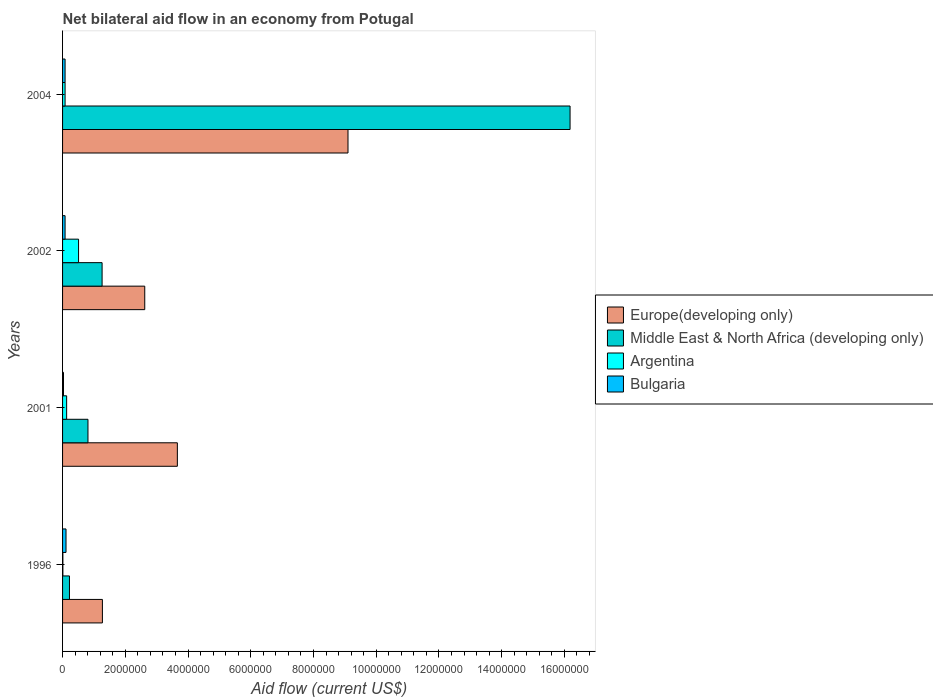How many different coloured bars are there?
Your answer should be very brief. 4. Are the number of bars per tick equal to the number of legend labels?
Offer a very short reply. Yes. Are the number of bars on each tick of the Y-axis equal?
Provide a succinct answer. Yes. What is the net bilateral aid flow in Argentina in 2001?
Provide a short and direct response. 1.30e+05. Across all years, what is the maximum net bilateral aid flow in Middle East & North Africa (developing only)?
Your answer should be very brief. 1.62e+07. In which year was the net bilateral aid flow in Middle East & North Africa (developing only) maximum?
Offer a terse response. 2004. What is the total net bilateral aid flow in Middle East & North Africa (developing only) in the graph?
Your answer should be very brief. 1.85e+07. What is the difference between the net bilateral aid flow in Europe(developing only) in 2001 and that in 2004?
Ensure brevity in your answer.  -5.44e+06. What is the average net bilateral aid flow in Europe(developing only) per year?
Your response must be concise. 4.16e+06. In the year 2004, what is the difference between the net bilateral aid flow in Bulgaria and net bilateral aid flow in Argentina?
Provide a succinct answer. 0. What is the ratio of the net bilateral aid flow in Bulgaria in 2001 to that in 2002?
Your response must be concise. 0.38. Is the net bilateral aid flow in Europe(developing only) in 2002 less than that in 2004?
Give a very brief answer. Yes. What is the difference between the highest and the second highest net bilateral aid flow in Middle East & North Africa (developing only)?
Make the answer very short. 1.49e+07. What is the difference between the highest and the lowest net bilateral aid flow in Bulgaria?
Offer a very short reply. 8.00e+04. Is the sum of the net bilateral aid flow in Argentina in 1996 and 2001 greater than the maximum net bilateral aid flow in Europe(developing only) across all years?
Ensure brevity in your answer.  No. Is it the case that in every year, the sum of the net bilateral aid flow in Middle East & North Africa (developing only) and net bilateral aid flow in Bulgaria is greater than the sum of net bilateral aid flow in Europe(developing only) and net bilateral aid flow in Argentina?
Your answer should be very brief. Yes. What does the 2nd bar from the top in 2002 represents?
Offer a very short reply. Argentina. Is it the case that in every year, the sum of the net bilateral aid flow in Middle East & North Africa (developing only) and net bilateral aid flow in Argentina is greater than the net bilateral aid flow in Europe(developing only)?
Provide a short and direct response. No. How many years are there in the graph?
Give a very brief answer. 4. What is the difference between two consecutive major ticks on the X-axis?
Keep it short and to the point. 2.00e+06. Does the graph contain any zero values?
Offer a very short reply. No. Does the graph contain grids?
Ensure brevity in your answer.  No. Where does the legend appear in the graph?
Offer a terse response. Center right. What is the title of the graph?
Your answer should be compact. Net bilateral aid flow in an economy from Potugal. What is the label or title of the Y-axis?
Ensure brevity in your answer.  Years. What is the Aid flow (current US$) of Europe(developing only) in 1996?
Your answer should be compact. 1.27e+06. What is the Aid flow (current US$) in Argentina in 1996?
Offer a terse response. 10000. What is the Aid flow (current US$) of Europe(developing only) in 2001?
Keep it short and to the point. 3.66e+06. What is the Aid flow (current US$) in Middle East & North Africa (developing only) in 2001?
Give a very brief answer. 8.10e+05. What is the Aid flow (current US$) of Argentina in 2001?
Your response must be concise. 1.30e+05. What is the Aid flow (current US$) in Bulgaria in 2001?
Provide a succinct answer. 3.00e+04. What is the Aid flow (current US$) in Europe(developing only) in 2002?
Make the answer very short. 2.62e+06. What is the Aid flow (current US$) of Middle East & North Africa (developing only) in 2002?
Give a very brief answer. 1.26e+06. What is the Aid flow (current US$) of Argentina in 2002?
Provide a succinct answer. 5.10e+05. What is the Aid flow (current US$) in Bulgaria in 2002?
Provide a short and direct response. 8.00e+04. What is the Aid flow (current US$) of Europe(developing only) in 2004?
Your answer should be compact. 9.10e+06. What is the Aid flow (current US$) in Middle East & North Africa (developing only) in 2004?
Your answer should be very brief. 1.62e+07. What is the Aid flow (current US$) in Argentina in 2004?
Provide a short and direct response. 8.00e+04. What is the Aid flow (current US$) in Bulgaria in 2004?
Ensure brevity in your answer.  8.00e+04. Across all years, what is the maximum Aid flow (current US$) in Europe(developing only)?
Offer a terse response. 9.10e+06. Across all years, what is the maximum Aid flow (current US$) in Middle East & North Africa (developing only)?
Make the answer very short. 1.62e+07. Across all years, what is the maximum Aid flow (current US$) in Argentina?
Your answer should be very brief. 5.10e+05. Across all years, what is the minimum Aid flow (current US$) in Europe(developing only)?
Make the answer very short. 1.27e+06. Across all years, what is the minimum Aid flow (current US$) in Argentina?
Ensure brevity in your answer.  10000. What is the total Aid flow (current US$) in Europe(developing only) in the graph?
Your response must be concise. 1.66e+07. What is the total Aid flow (current US$) of Middle East & North Africa (developing only) in the graph?
Make the answer very short. 1.85e+07. What is the total Aid flow (current US$) in Argentina in the graph?
Offer a very short reply. 7.30e+05. What is the total Aid flow (current US$) of Bulgaria in the graph?
Offer a very short reply. 3.00e+05. What is the difference between the Aid flow (current US$) in Europe(developing only) in 1996 and that in 2001?
Make the answer very short. -2.39e+06. What is the difference between the Aid flow (current US$) in Middle East & North Africa (developing only) in 1996 and that in 2001?
Offer a very short reply. -5.90e+05. What is the difference between the Aid flow (current US$) of Argentina in 1996 and that in 2001?
Provide a short and direct response. -1.20e+05. What is the difference between the Aid flow (current US$) in Europe(developing only) in 1996 and that in 2002?
Your answer should be very brief. -1.35e+06. What is the difference between the Aid flow (current US$) of Middle East & North Africa (developing only) in 1996 and that in 2002?
Ensure brevity in your answer.  -1.04e+06. What is the difference between the Aid flow (current US$) of Argentina in 1996 and that in 2002?
Make the answer very short. -5.00e+05. What is the difference between the Aid flow (current US$) of Europe(developing only) in 1996 and that in 2004?
Ensure brevity in your answer.  -7.83e+06. What is the difference between the Aid flow (current US$) of Middle East & North Africa (developing only) in 1996 and that in 2004?
Your response must be concise. -1.60e+07. What is the difference between the Aid flow (current US$) in Europe(developing only) in 2001 and that in 2002?
Your answer should be very brief. 1.04e+06. What is the difference between the Aid flow (current US$) of Middle East & North Africa (developing only) in 2001 and that in 2002?
Offer a very short reply. -4.50e+05. What is the difference between the Aid flow (current US$) of Argentina in 2001 and that in 2002?
Give a very brief answer. -3.80e+05. What is the difference between the Aid flow (current US$) of Bulgaria in 2001 and that in 2002?
Make the answer very short. -5.00e+04. What is the difference between the Aid flow (current US$) in Europe(developing only) in 2001 and that in 2004?
Offer a terse response. -5.44e+06. What is the difference between the Aid flow (current US$) in Middle East & North Africa (developing only) in 2001 and that in 2004?
Keep it short and to the point. -1.54e+07. What is the difference between the Aid flow (current US$) of Bulgaria in 2001 and that in 2004?
Provide a succinct answer. -5.00e+04. What is the difference between the Aid flow (current US$) of Europe(developing only) in 2002 and that in 2004?
Offer a very short reply. -6.48e+06. What is the difference between the Aid flow (current US$) of Middle East & North Africa (developing only) in 2002 and that in 2004?
Make the answer very short. -1.49e+07. What is the difference between the Aid flow (current US$) in Bulgaria in 2002 and that in 2004?
Offer a very short reply. 0. What is the difference between the Aid flow (current US$) of Europe(developing only) in 1996 and the Aid flow (current US$) of Argentina in 2001?
Provide a succinct answer. 1.14e+06. What is the difference between the Aid flow (current US$) of Europe(developing only) in 1996 and the Aid flow (current US$) of Bulgaria in 2001?
Offer a very short reply. 1.24e+06. What is the difference between the Aid flow (current US$) in Middle East & North Africa (developing only) in 1996 and the Aid flow (current US$) in Argentina in 2001?
Your answer should be very brief. 9.00e+04. What is the difference between the Aid flow (current US$) in Argentina in 1996 and the Aid flow (current US$) in Bulgaria in 2001?
Provide a short and direct response. -2.00e+04. What is the difference between the Aid flow (current US$) in Europe(developing only) in 1996 and the Aid flow (current US$) in Argentina in 2002?
Make the answer very short. 7.60e+05. What is the difference between the Aid flow (current US$) in Europe(developing only) in 1996 and the Aid flow (current US$) in Bulgaria in 2002?
Your answer should be compact. 1.19e+06. What is the difference between the Aid flow (current US$) in Europe(developing only) in 1996 and the Aid flow (current US$) in Middle East & North Africa (developing only) in 2004?
Make the answer very short. -1.49e+07. What is the difference between the Aid flow (current US$) of Europe(developing only) in 1996 and the Aid flow (current US$) of Argentina in 2004?
Make the answer very short. 1.19e+06. What is the difference between the Aid flow (current US$) in Europe(developing only) in 1996 and the Aid flow (current US$) in Bulgaria in 2004?
Ensure brevity in your answer.  1.19e+06. What is the difference between the Aid flow (current US$) of Europe(developing only) in 2001 and the Aid flow (current US$) of Middle East & North Africa (developing only) in 2002?
Your answer should be very brief. 2.40e+06. What is the difference between the Aid flow (current US$) of Europe(developing only) in 2001 and the Aid flow (current US$) of Argentina in 2002?
Keep it short and to the point. 3.15e+06. What is the difference between the Aid flow (current US$) of Europe(developing only) in 2001 and the Aid flow (current US$) of Bulgaria in 2002?
Offer a very short reply. 3.58e+06. What is the difference between the Aid flow (current US$) in Middle East & North Africa (developing only) in 2001 and the Aid flow (current US$) in Bulgaria in 2002?
Make the answer very short. 7.30e+05. What is the difference between the Aid flow (current US$) of Europe(developing only) in 2001 and the Aid flow (current US$) of Middle East & North Africa (developing only) in 2004?
Provide a succinct answer. -1.25e+07. What is the difference between the Aid flow (current US$) of Europe(developing only) in 2001 and the Aid flow (current US$) of Argentina in 2004?
Your answer should be compact. 3.58e+06. What is the difference between the Aid flow (current US$) of Europe(developing only) in 2001 and the Aid flow (current US$) of Bulgaria in 2004?
Give a very brief answer. 3.58e+06. What is the difference between the Aid flow (current US$) in Middle East & North Africa (developing only) in 2001 and the Aid flow (current US$) in Argentina in 2004?
Your answer should be very brief. 7.30e+05. What is the difference between the Aid flow (current US$) in Middle East & North Africa (developing only) in 2001 and the Aid flow (current US$) in Bulgaria in 2004?
Your response must be concise. 7.30e+05. What is the difference between the Aid flow (current US$) in Europe(developing only) in 2002 and the Aid flow (current US$) in Middle East & North Africa (developing only) in 2004?
Your answer should be compact. -1.36e+07. What is the difference between the Aid flow (current US$) of Europe(developing only) in 2002 and the Aid flow (current US$) of Argentina in 2004?
Offer a very short reply. 2.54e+06. What is the difference between the Aid flow (current US$) of Europe(developing only) in 2002 and the Aid flow (current US$) of Bulgaria in 2004?
Ensure brevity in your answer.  2.54e+06. What is the difference between the Aid flow (current US$) in Middle East & North Africa (developing only) in 2002 and the Aid flow (current US$) in Argentina in 2004?
Offer a very short reply. 1.18e+06. What is the difference between the Aid flow (current US$) of Middle East & North Africa (developing only) in 2002 and the Aid flow (current US$) of Bulgaria in 2004?
Ensure brevity in your answer.  1.18e+06. What is the average Aid flow (current US$) of Europe(developing only) per year?
Provide a short and direct response. 4.16e+06. What is the average Aid flow (current US$) of Middle East & North Africa (developing only) per year?
Your response must be concise. 4.62e+06. What is the average Aid flow (current US$) of Argentina per year?
Keep it short and to the point. 1.82e+05. What is the average Aid flow (current US$) of Bulgaria per year?
Your answer should be compact. 7.50e+04. In the year 1996, what is the difference between the Aid flow (current US$) of Europe(developing only) and Aid flow (current US$) of Middle East & North Africa (developing only)?
Provide a short and direct response. 1.05e+06. In the year 1996, what is the difference between the Aid flow (current US$) of Europe(developing only) and Aid flow (current US$) of Argentina?
Offer a terse response. 1.26e+06. In the year 1996, what is the difference between the Aid flow (current US$) of Europe(developing only) and Aid flow (current US$) of Bulgaria?
Offer a terse response. 1.16e+06. In the year 1996, what is the difference between the Aid flow (current US$) of Middle East & North Africa (developing only) and Aid flow (current US$) of Argentina?
Keep it short and to the point. 2.10e+05. In the year 1996, what is the difference between the Aid flow (current US$) of Middle East & North Africa (developing only) and Aid flow (current US$) of Bulgaria?
Provide a short and direct response. 1.10e+05. In the year 2001, what is the difference between the Aid flow (current US$) of Europe(developing only) and Aid flow (current US$) of Middle East & North Africa (developing only)?
Keep it short and to the point. 2.85e+06. In the year 2001, what is the difference between the Aid flow (current US$) of Europe(developing only) and Aid flow (current US$) of Argentina?
Your answer should be compact. 3.53e+06. In the year 2001, what is the difference between the Aid flow (current US$) of Europe(developing only) and Aid flow (current US$) of Bulgaria?
Make the answer very short. 3.63e+06. In the year 2001, what is the difference between the Aid flow (current US$) of Middle East & North Africa (developing only) and Aid flow (current US$) of Argentina?
Make the answer very short. 6.80e+05. In the year 2001, what is the difference between the Aid flow (current US$) in Middle East & North Africa (developing only) and Aid flow (current US$) in Bulgaria?
Your response must be concise. 7.80e+05. In the year 2001, what is the difference between the Aid flow (current US$) of Argentina and Aid flow (current US$) of Bulgaria?
Make the answer very short. 1.00e+05. In the year 2002, what is the difference between the Aid flow (current US$) in Europe(developing only) and Aid flow (current US$) in Middle East & North Africa (developing only)?
Offer a very short reply. 1.36e+06. In the year 2002, what is the difference between the Aid flow (current US$) in Europe(developing only) and Aid flow (current US$) in Argentina?
Keep it short and to the point. 2.11e+06. In the year 2002, what is the difference between the Aid flow (current US$) in Europe(developing only) and Aid flow (current US$) in Bulgaria?
Offer a terse response. 2.54e+06. In the year 2002, what is the difference between the Aid flow (current US$) of Middle East & North Africa (developing only) and Aid flow (current US$) of Argentina?
Keep it short and to the point. 7.50e+05. In the year 2002, what is the difference between the Aid flow (current US$) of Middle East & North Africa (developing only) and Aid flow (current US$) of Bulgaria?
Offer a terse response. 1.18e+06. In the year 2004, what is the difference between the Aid flow (current US$) in Europe(developing only) and Aid flow (current US$) in Middle East & North Africa (developing only)?
Your answer should be compact. -7.08e+06. In the year 2004, what is the difference between the Aid flow (current US$) of Europe(developing only) and Aid flow (current US$) of Argentina?
Your answer should be very brief. 9.02e+06. In the year 2004, what is the difference between the Aid flow (current US$) of Europe(developing only) and Aid flow (current US$) of Bulgaria?
Make the answer very short. 9.02e+06. In the year 2004, what is the difference between the Aid flow (current US$) of Middle East & North Africa (developing only) and Aid flow (current US$) of Argentina?
Offer a very short reply. 1.61e+07. In the year 2004, what is the difference between the Aid flow (current US$) in Middle East & North Africa (developing only) and Aid flow (current US$) in Bulgaria?
Your answer should be very brief. 1.61e+07. What is the ratio of the Aid flow (current US$) of Europe(developing only) in 1996 to that in 2001?
Your answer should be compact. 0.35. What is the ratio of the Aid flow (current US$) of Middle East & North Africa (developing only) in 1996 to that in 2001?
Ensure brevity in your answer.  0.27. What is the ratio of the Aid flow (current US$) of Argentina in 1996 to that in 2001?
Keep it short and to the point. 0.08. What is the ratio of the Aid flow (current US$) in Bulgaria in 1996 to that in 2001?
Offer a very short reply. 3.67. What is the ratio of the Aid flow (current US$) of Europe(developing only) in 1996 to that in 2002?
Offer a very short reply. 0.48. What is the ratio of the Aid flow (current US$) in Middle East & North Africa (developing only) in 1996 to that in 2002?
Your answer should be compact. 0.17. What is the ratio of the Aid flow (current US$) in Argentina in 1996 to that in 2002?
Offer a terse response. 0.02. What is the ratio of the Aid flow (current US$) of Bulgaria in 1996 to that in 2002?
Your response must be concise. 1.38. What is the ratio of the Aid flow (current US$) in Europe(developing only) in 1996 to that in 2004?
Keep it short and to the point. 0.14. What is the ratio of the Aid flow (current US$) of Middle East & North Africa (developing only) in 1996 to that in 2004?
Keep it short and to the point. 0.01. What is the ratio of the Aid flow (current US$) of Bulgaria in 1996 to that in 2004?
Ensure brevity in your answer.  1.38. What is the ratio of the Aid flow (current US$) in Europe(developing only) in 2001 to that in 2002?
Ensure brevity in your answer.  1.4. What is the ratio of the Aid flow (current US$) of Middle East & North Africa (developing only) in 2001 to that in 2002?
Ensure brevity in your answer.  0.64. What is the ratio of the Aid flow (current US$) in Argentina in 2001 to that in 2002?
Offer a very short reply. 0.25. What is the ratio of the Aid flow (current US$) of Bulgaria in 2001 to that in 2002?
Provide a short and direct response. 0.38. What is the ratio of the Aid flow (current US$) in Europe(developing only) in 2001 to that in 2004?
Ensure brevity in your answer.  0.4. What is the ratio of the Aid flow (current US$) of Middle East & North Africa (developing only) in 2001 to that in 2004?
Give a very brief answer. 0.05. What is the ratio of the Aid flow (current US$) of Argentina in 2001 to that in 2004?
Provide a short and direct response. 1.62. What is the ratio of the Aid flow (current US$) in Europe(developing only) in 2002 to that in 2004?
Give a very brief answer. 0.29. What is the ratio of the Aid flow (current US$) of Middle East & North Africa (developing only) in 2002 to that in 2004?
Provide a short and direct response. 0.08. What is the ratio of the Aid flow (current US$) in Argentina in 2002 to that in 2004?
Your answer should be compact. 6.38. What is the difference between the highest and the second highest Aid flow (current US$) of Europe(developing only)?
Keep it short and to the point. 5.44e+06. What is the difference between the highest and the second highest Aid flow (current US$) of Middle East & North Africa (developing only)?
Your response must be concise. 1.49e+07. What is the difference between the highest and the second highest Aid flow (current US$) in Argentina?
Your answer should be compact. 3.80e+05. What is the difference between the highest and the lowest Aid flow (current US$) of Europe(developing only)?
Give a very brief answer. 7.83e+06. What is the difference between the highest and the lowest Aid flow (current US$) of Middle East & North Africa (developing only)?
Ensure brevity in your answer.  1.60e+07. What is the difference between the highest and the lowest Aid flow (current US$) in Argentina?
Your answer should be compact. 5.00e+05. 